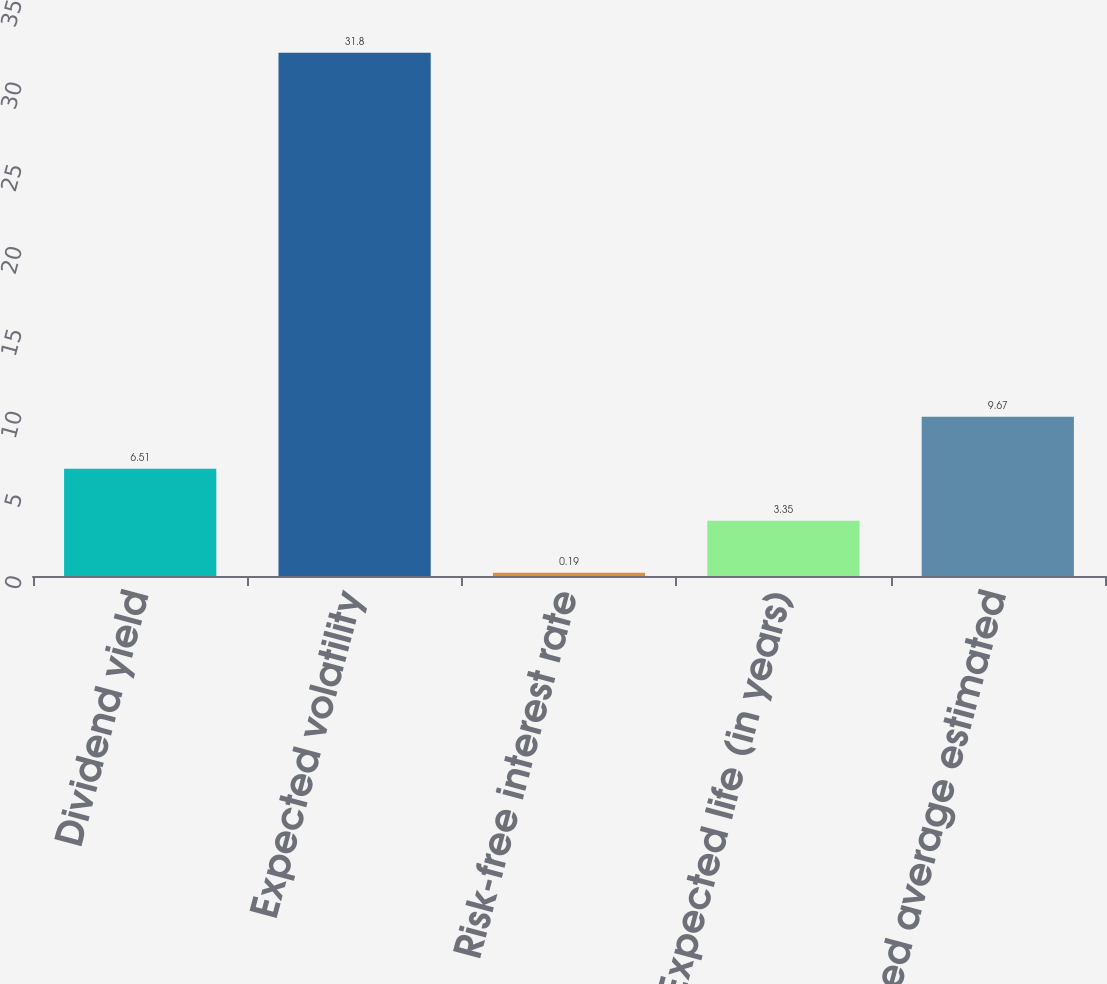Convert chart to OTSL. <chart><loc_0><loc_0><loc_500><loc_500><bar_chart><fcel>Dividend yield<fcel>Expected volatility<fcel>Risk-free interest rate<fcel>Expected life (in years)<fcel>Weighted average estimated<nl><fcel>6.51<fcel>31.8<fcel>0.19<fcel>3.35<fcel>9.67<nl></chart> 